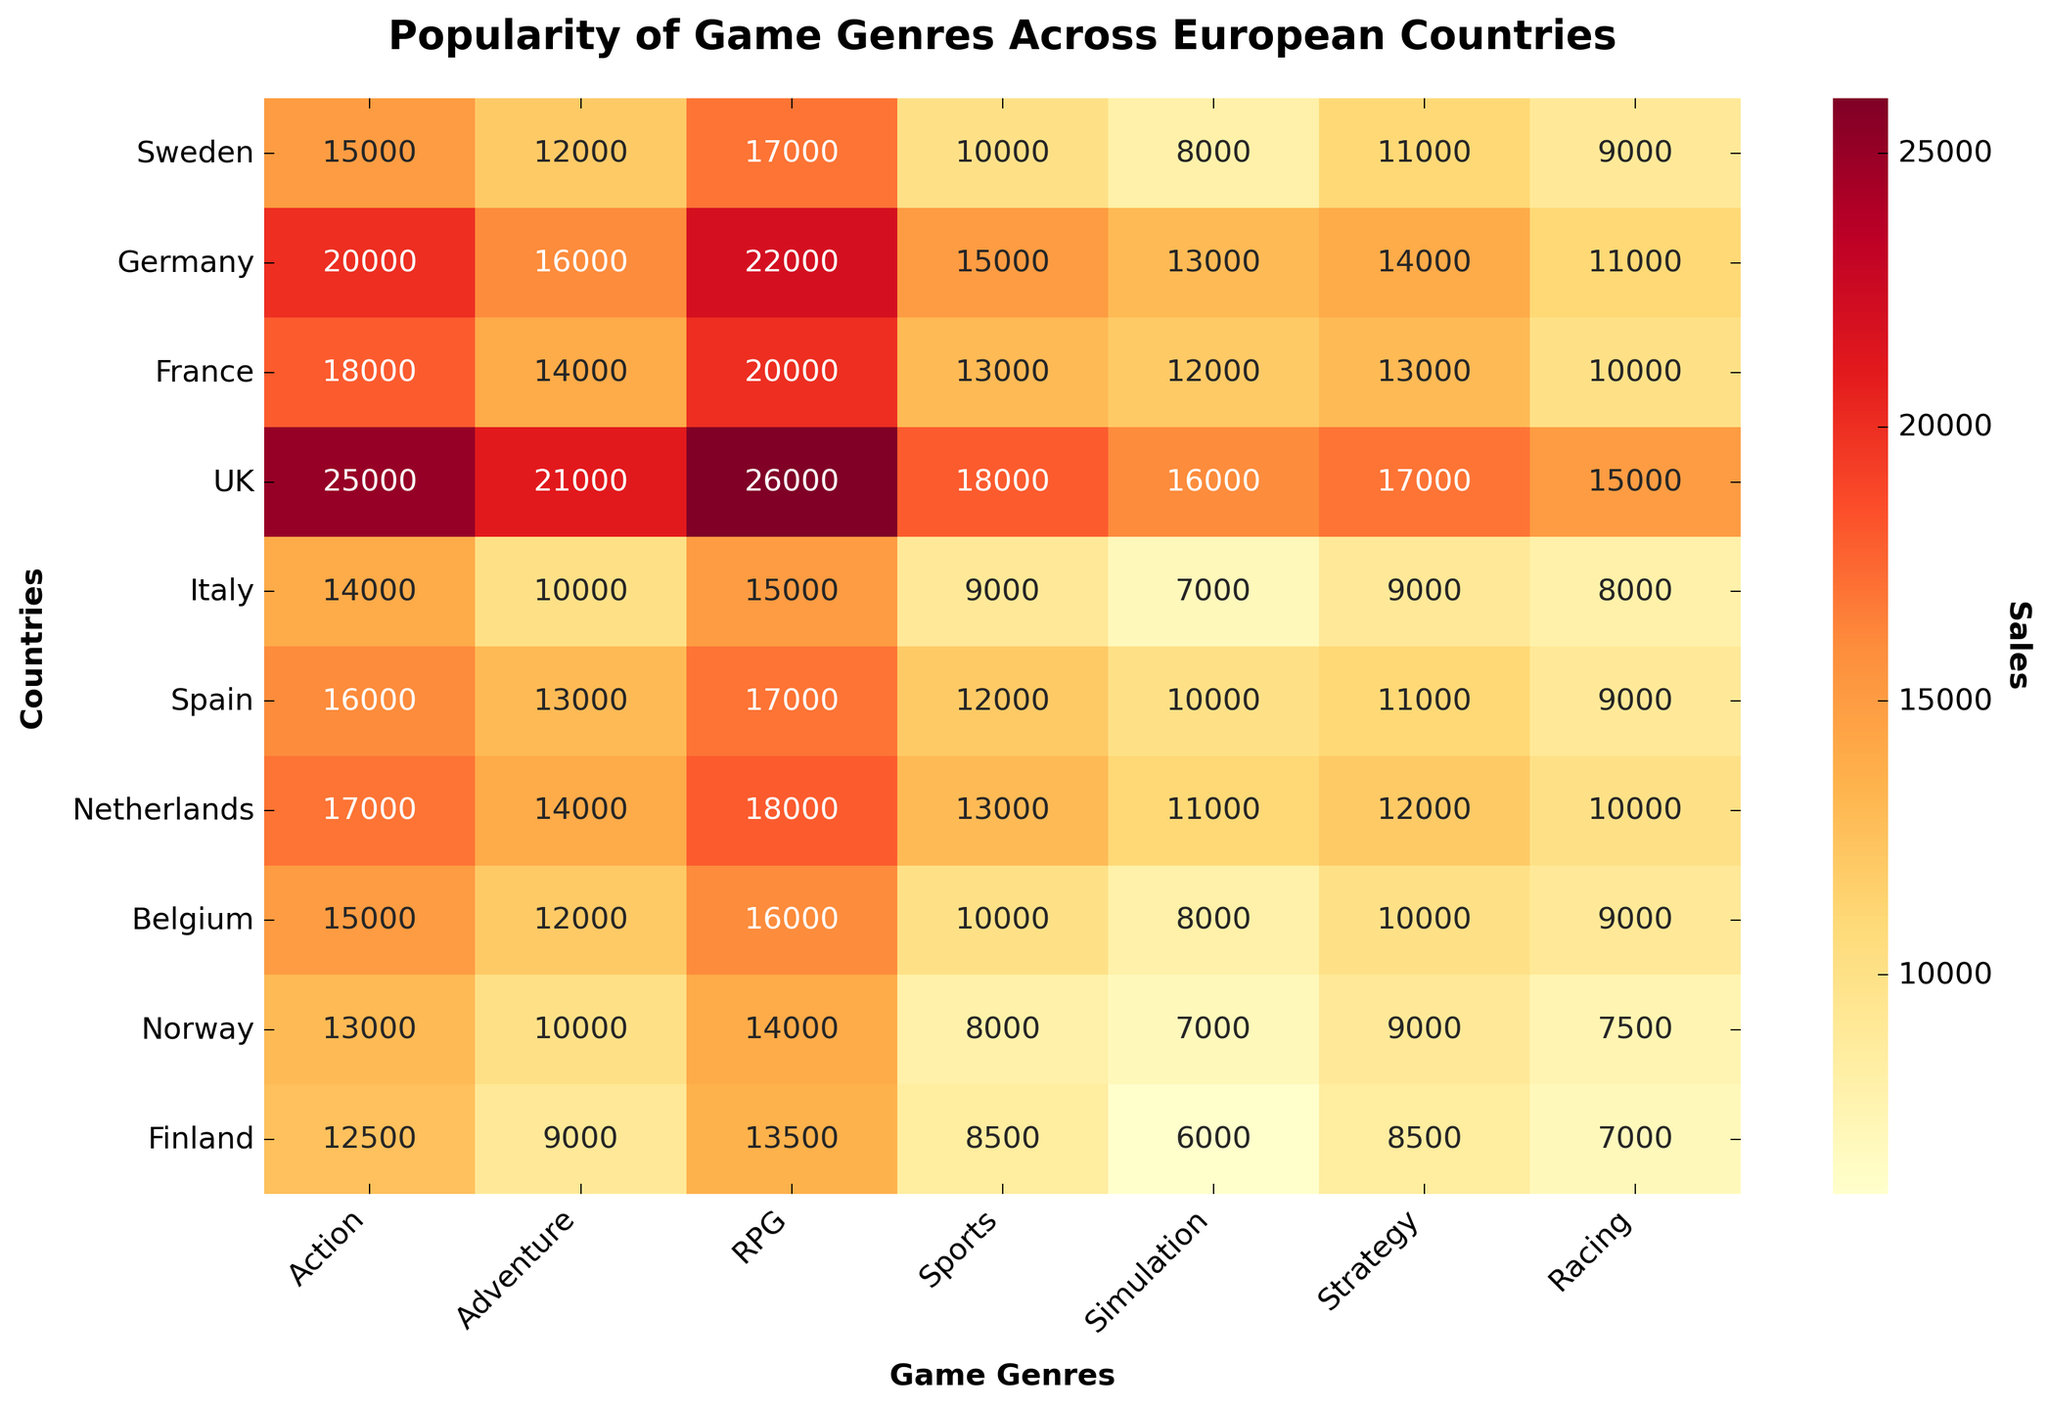What is the most popular game genre in the UK? To find the most popular game genre in the UK, look at the row for the UK and find the highest value. "Action" has the highest value with 25000.
Answer: Action Which country has the lowest sales for the Simulation genre? Locate the Simulation column and identify the lowest value. Finland has the lowest value with 6000 sales.
Answer: Finland What is the total number of sales for Adventure games in France and Germany combined? Add the Adventure sales figures for France (14000) and Germany (16000). The sum is 14000 + 16000 = 30000.
Answer: 30000 Is Action more popular in Sweden or Italy? Compare the values for Action in Sweden (15000) and Italy (14000). Since 15000 is greater than 14000, Action is more popular in Sweden.
Answer: Sweden What is the average sales figure for RPG games across all the countries? Add up all the sales figures for RPG games and divide by the number of countries: (17000 + 22000 + 20000 + 26000 + 15000 + 17000 + 18000 + 16000 + 14000 + 13500) = 178500, then 178500 / 10 = 17850.
Answer: 17850 Which game genre is the least popular in Norway? Look for the smallest number in the Norway row. Simulation and Strategy both have the lowest value, 7000.
Answer: Simulation and Strategy Which country has the highest total game sales across all genres? Sum the sales figures for each country and compare the totals. The UK has the highest sum of 138000. Example sums: UK = 25000 + 21000 + 26000 + 18000 + 16000 + 17000 + 15000 = 138000.
Answer: UK How do the sales of Racing games in Finland compare to those in Norway? Compare the values for Racing in Finland (7000) and Norway (7500). Since 7500 > 7000, Racing is more popular in Norway.
Answer: Norway How many countries have higher sales in Strategy than Simulation? Count the number of countries where the value in the Strategy column is greater than in the Simulation column. There are 6 countries where this is true (Sweden, Germany, France, UK, Spain, Netherlands).
Answer: 6 What are the top two genres in Belgium based on sales? Look at the values for each genre in Belgium and identify the top two. The top two genres in Belgium are RPG (16000) and Action (15000).
Answer: RPG and Action 